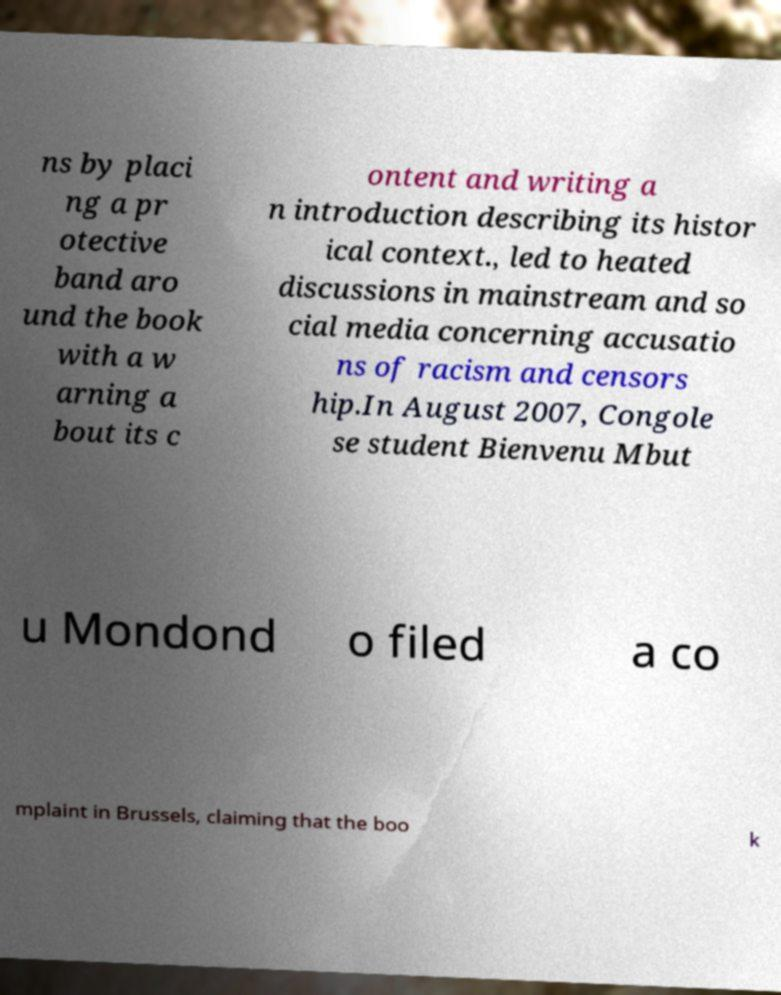Please identify and transcribe the text found in this image. ns by placi ng a pr otective band aro und the book with a w arning a bout its c ontent and writing a n introduction describing its histor ical context., led to heated discussions in mainstream and so cial media concerning accusatio ns of racism and censors hip.In August 2007, Congole se student Bienvenu Mbut u Mondond o filed a co mplaint in Brussels, claiming that the boo k 